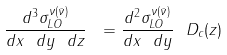Convert formula to latex. <formula><loc_0><loc_0><loc_500><loc_500>\frac { d ^ { 3 } \sigma _ { L O } ^ { \nu ( \bar { \nu } ) } } { d x \ d y \ d z } \ = \frac { d ^ { 2 } \sigma _ { L O } ^ { \nu ( \bar { \nu } ) } } { d x \ d y } \ D _ { c } ( z )</formula> 